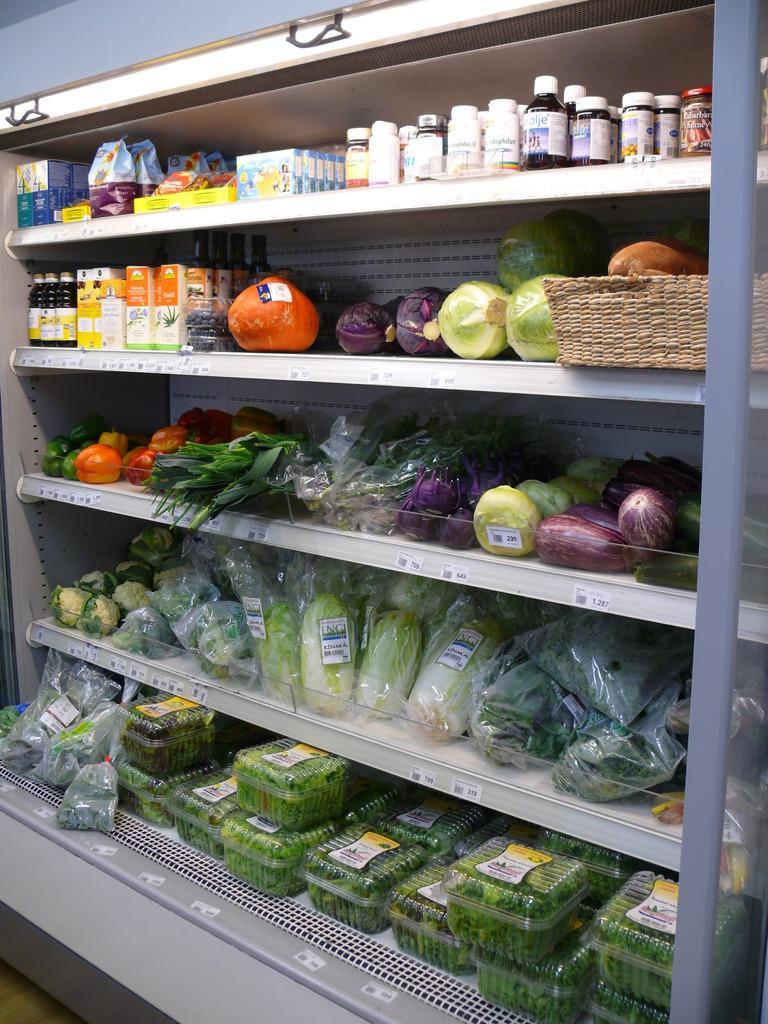Describe this image in one or two sentences. In this image we can see there are a few food items, drinks, vegetables are arranged in a rack. 